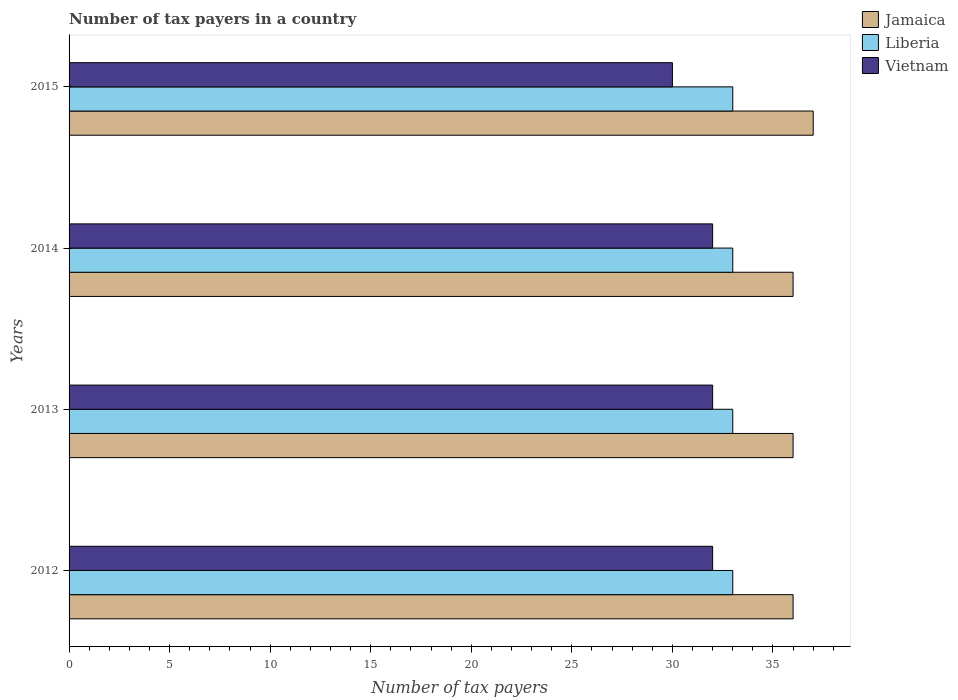Are the number of bars on each tick of the Y-axis equal?
Provide a short and direct response. Yes. How many bars are there on the 2nd tick from the top?
Make the answer very short. 3. What is the label of the 1st group of bars from the top?
Make the answer very short. 2015. In how many cases, is the number of bars for a given year not equal to the number of legend labels?
Your answer should be very brief. 0. What is the number of tax payers in in Jamaica in 2012?
Ensure brevity in your answer.  36. Across all years, what is the maximum number of tax payers in in Liberia?
Provide a short and direct response. 33. Across all years, what is the minimum number of tax payers in in Jamaica?
Make the answer very short. 36. In which year was the number of tax payers in in Vietnam maximum?
Your response must be concise. 2012. What is the total number of tax payers in in Vietnam in the graph?
Provide a succinct answer. 126. What is the difference between the number of tax payers in in Vietnam in 2014 and that in 2015?
Ensure brevity in your answer.  2. What is the difference between the number of tax payers in in Jamaica in 2014 and the number of tax payers in in Liberia in 2013?
Keep it short and to the point. 3. What is the average number of tax payers in in Jamaica per year?
Your answer should be compact. 36.25. In the year 2014, what is the difference between the number of tax payers in in Vietnam and number of tax payers in in Liberia?
Offer a very short reply. -1. In how many years, is the number of tax payers in in Jamaica greater than 29 ?
Provide a short and direct response. 4. Is the number of tax payers in in Vietnam in 2012 less than that in 2013?
Make the answer very short. No. Is the difference between the number of tax payers in in Vietnam in 2013 and 2014 greater than the difference between the number of tax payers in in Liberia in 2013 and 2014?
Keep it short and to the point. No. What is the difference between the highest and the second highest number of tax payers in in Vietnam?
Keep it short and to the point. 0. What does the 1st bar from the top in 2013 represents?
Give a very brief answer. Vietnam. What does the 1st bar from the bottom in 2012 represents?
Offer a very short reply. Jamaica. Is it the case that in every year, the sum of the number of tax payers in in Vietnam and number of tax payers in in Liberia is greater than the number of tax payers in in Jamaica?
Your answer should be compact. Yes. How many years are there in the graph?
Offer a very short reply. 4. What is the difference between two consecutive major ticks on the X-axis?
Keep it short and to the point. 5. Are the values on the major ticks of X-axis written in scientific E-notation?
Offer a terse response. No. How many legend labels are there?
Your answer should be very brief. 3. What is the title of the graph?
Provide a short and direct response. Number of tax payers in a country. What is the label or title of the X-axis?
Your answer should be compact. Number of tax payers. What is the label or title of the Y-axis?
Your response must be concise. Years. What is the Number of tax payers of Liberia in 2012?
Provide a short and direct response. 33. What is the Number of tax payers in Jamaica in 2013?
Provide a succinct answer. 36. What is the Number of tax payers of Liberia in 2013?
Provide a succinct answer. 33. What is the Number of tax payers of Jamaica in 2015?
Give a very brief answer. 37. What is the Number of tax payers in Liberia in 2015?
Make the answer very short. 33. Across all years, what is the maximum Number of tax payers in Vietnam?
Provide a short and direct response. 32. Across all years, what is the minimum Number of tax payers of Liberia?
Ensure brevity in your answer.  33. Across all years, what is the minimum Number of tax payers of Vietnam?
Your response must be concise. 30. What is the total Number of tax payers in Jamaica in the graph?
Provide a short and direct response. 145. What is the total Number of tax payers in Liberia in the graph?
Keep it short and to the point. 132. What is the total Number of tax payers of Vietnam in the graph?
Ensure brevity in your answer.  126. What is the difference between the Number of tax payers of Jamaica in 2012 and that in 2013?
Offer a terse response. 0. What is the difference between the Number of tax payers of Vietnam in 2012 and that in 2013?
Keep it short and to the point. 0. What is the difference between the Number of tax payers of Vietnam in 2012 and that in 2014?
Offer a terse response. 0. What is the difference between the Number of tax payers of Vietnam in 2012 and that in 2015?
Make the answer very short. 2. What is the difference between the Number of tax payers of Jamaica in 2013 and that in 2014?
Your response must be concise. 0. What is the difference between the Number of tax payers in Jamaica in 2013 and that in 2015?
Provide a short and direct response. -1. What is the difference between the Number of tax payers of Liberia in 2013 and that in 2015?
Ensure brevity in your answer.  0. What is the difference between the Number of tax payers in Jamaica in 2014 and that in 2015?
Your answer should be compact. -1. What is the difference between the Number of tax payers in Jamaica in 2012 and the Number of tax payers in Vietnam in 2013?
Make the answer very short. 4. What is the difference between the Number of tax payers in Liberia in 2012 and the Number of tax payers in Vietnam in 2014?
Your answer should be compact. 1. What is the difference between the Number of tax payers of Jamaica in 2012 and the Number of tax payers of Liberia in 2015?
Provide a succinct answer. 3. What is the difference between the Number of tax payers in Jamaica in 2012 and the Number of tax payers in Vietnam in 2015?
Your answer should be compact. 6. What is the difference between the Number of tax payers of Liberia in 2012 and the Number of tax payers of Vietnam in 2015?
Offer a terse response. 3. What is the difference between the Number of tax payers in Jamaica in 2013 and the Number of tax payers in Vietnam in 2014?
Your answer should be compact. 4. What is the average Number of tax payers of Jamaica per year?
Make the answer very short. 36.25. What is the average Number of tax payers in Vietnam per year?
Ensure brevity in your answer.  31.5. In the year 2012, what is the difference between the Number of tax payers in Jamaica and Number of tax payers in Liberia?
Your answer should be very brief. 3. In the year 2012, what is the difference between the Number of tax payers in Jamaica and Number of tax payers in Vietnam?
Offer a very short reply. 4. In the year 2013, what is the difference between the Number of tax payers in Jamaica and Number of tax payers in Liberia?
Give a very brief answer. 3. In the year 2013, what is the difference between the Number of tax payers of Liberia and Number of tax payers of Vietnam?
Provide a short and direct response. 1. In the year 2014, what is the difference between the Number of tax payers of Jamaica and Number of tax payers of Liberia?
Your answer should be compact. 3. In the year 2014, what is the difference between the Number of tax payers in Jamaica and Number of tax payers in Vietnam?
Your response must be concise. 4. In the year 2015, what is the difference between the Number of tax payers of Liberia and Number of tax payers of Vietnam?
Keep it short and to the point. 3. What is the ratio of the Number of tax payers of Vietnam in 2012 to that in 2014?
Your answer should be compact. 1. What is the ratio of the Number of tax payers of Jamaica in 2012 to that in 2015?
Your answer should be compact. 0.97. What is the ratio of the Number of tax payers of Liberia in 2012 to that in 2015?
Offer a very short reply. 1. What is the ratio of the Number of tax payers in Vietnam in 2012 to that in 2015?
Your answer should be compact. 1.07. What is the ratio of the Number of tax payers in Jamaica in 2013 to that in 2015?
Provide a succinct answer. 0.97. What is the ratio of the Number of tax payers in Vietnam in 2013 to that in 2015?
Keep it short and to the point. 1.07. What is the ratio of the Number of tax payers in Vietnam in 2014 to that in 2015?
Make the answer very short. 1.07. What is the difference between the highest and the second highest Number of tax payers in Liberia?
Ensure brevity in your answer.  0. What is the difference between the highest and the second highest Number of tax payers of Vietnam?
Keep it short and to the point. 0. What is the difference between the highest and the lowest Number of tax payers of Liberia?
Offer a very short reply. 0. 